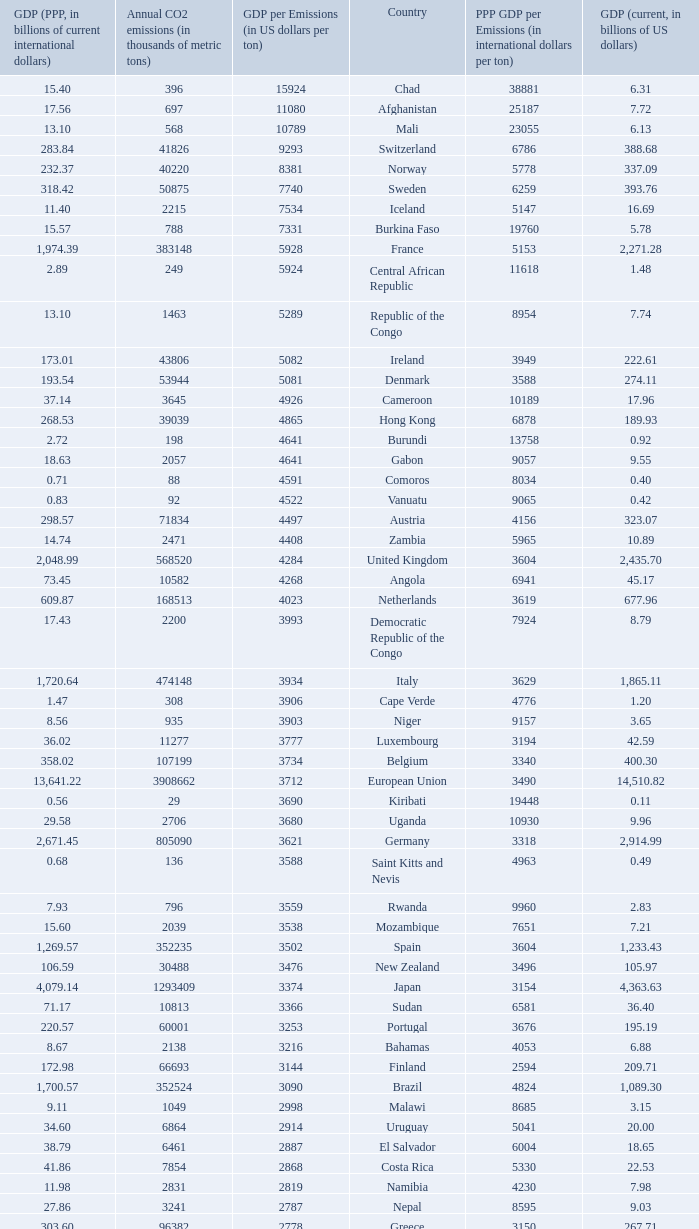When the annual co2 emissions (in thousands of metric tons) is 1811, what is the country? Haiti. 